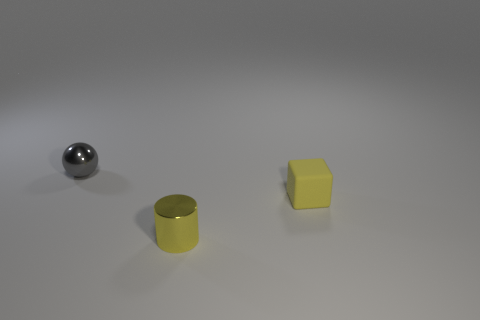How does the surface texture of the yellow object compare to the other objects? The yellow object has a matte surface that diffuses light, giving it a non-reflective appearance. In contrast, the spherical object is highly reflective with a specular finish, and the cylindrical object, while also having a somewhat reflective surface, is less shiny than the sphere. 